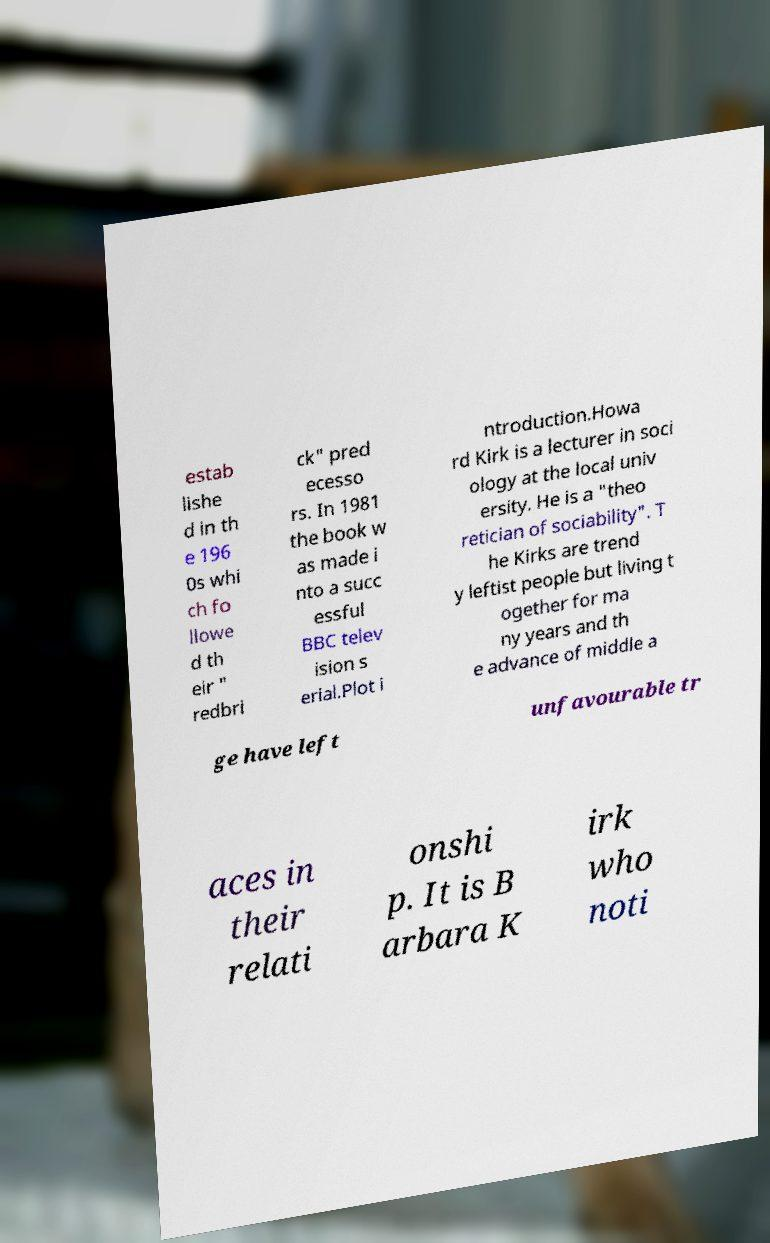Could you extract and type out the text from this image? estab lishe d in th e 196 0s whi ch fo llowe d th eir " redbri ck" pred ecesso rs. In 1981 the book w as made i nto a succ essful BBC telev ision s erial.Plot i ntroduction.Howa rd Kirk is a lecturer in soci ology at the local univ ersity. He is a "theo retician of sociability". T he Kirks are trend y leftist people but living t ogether for ma ny years and th e advance of middle a ge have left unfavourable tr aces in their relati onshi p. It is B arbara K irk who noti 